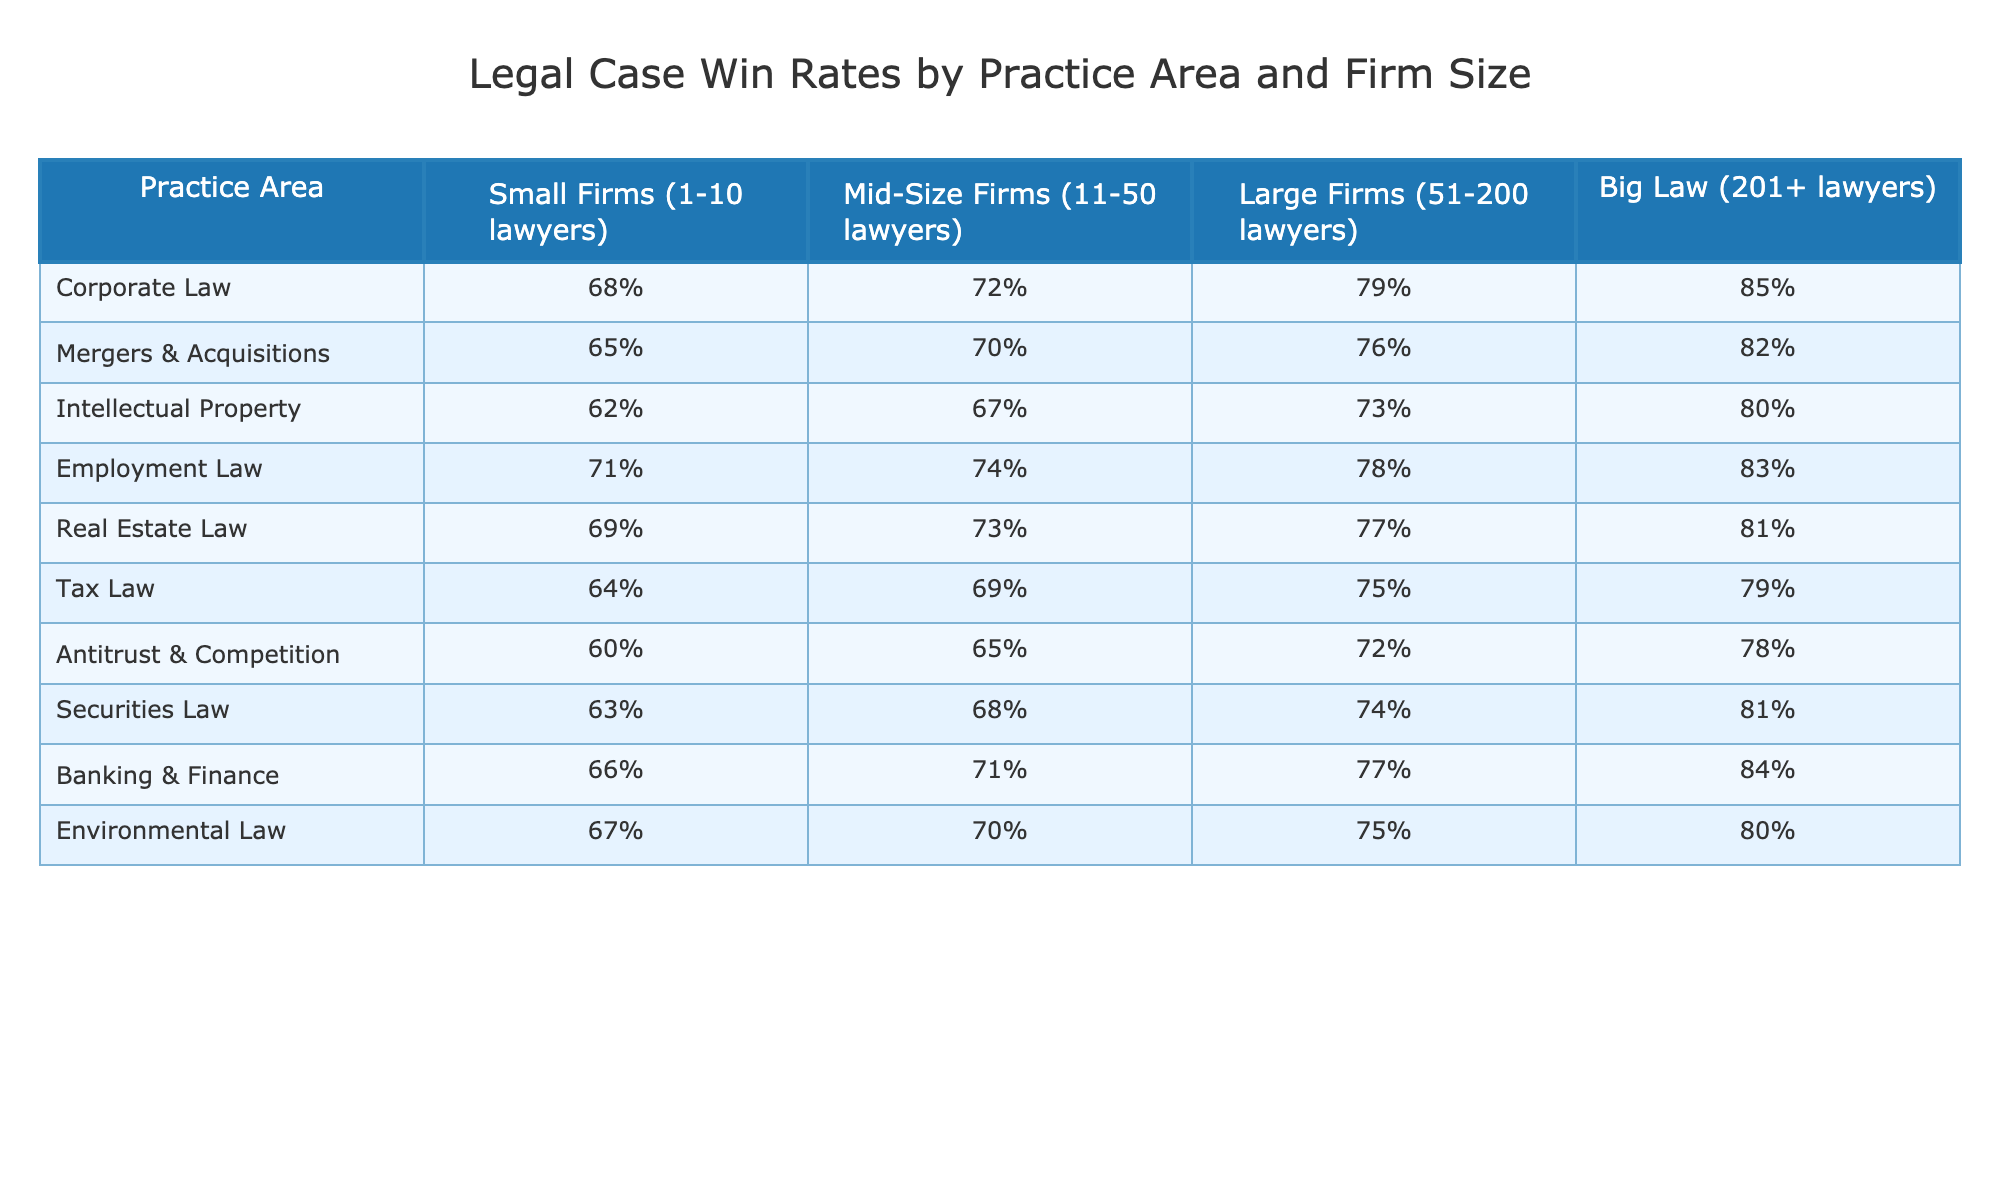What is the win rate for Employment Law in Big Law? The table shows the win rate for Employment Law in Big Law, which is represented in the last column under Big Law. Referring to the table, the win rate is 83%.
Answer: 83% Which practice area has the highest win rate for Small Firms? By reviewing the win rates for Small Firms in the table, I see that Employment Law has the highest win rate of 71%.
Answer: 71% How much higher is the win rate for Corporate Law in Big Law compared to Small Firms? The win rate for Corporate Law in Big Law is 85%, while for Small Firms, it's 68%. To find the difference, I subtract: 85% - 68% = 17%.
Answer: 17% Is the win rate for Antitrust & Competition higher in Mid-Size Firms than in Tax Law at Large Firms? The win rate for Antitrust & Competition in Mid-Size Firms is 65%, while the win rate for Tax Law at Large Firms is 75%. Since 65% is less than 75%, the answer is no.
Answer: No What is the average win rate across all practice areas for Large Firms? To find the average for Large Firms, I need to add all the win rates: (79 + 76 + 73 + 78 + 77 + 75 + 72 + 74 + 77 + 75) = 761. There are 10 practice areas, so the average is 761/10 = 76.1%.
Answer: 76.1% Which practice areas have a win rate greater than 70% for Mid-Size Firms? Checking the Mid-Size Firms column, the practice areas with a win rate greater than 70% are Corporate Law (72%), Mergers & Acquisitions (70%), Employment Law (74%), Real Estate Law (73%), and Banking & Finance (71%). This is a total of five practice areas.
Answer: 5 What is the difference in win rates between Intellectual Property in Big Law and Corporate Law in Small Firms? The win rate for Intellectual Property in Big Law is 80%, and for Corporate Law in Small Firms, it's 68%. Therefore, the difference is 80% - 68% = 12%.
Answer: 12% If you combine the win rates for Securities Law and Environmental Law in Large Firms, what is the total? The win rate for Securities Law in Large Firms is 74%, and for Environmental Law, it's 75%. Adding them together gives 74% + 75% = 149%.
Answer: 149% Which firm size has the lowest win rate for Real Estate Law? Looking at the win rates for Real Estate Law across firm sizes, Small Firms have a win rate of 69%, Mid-Size Firms have 73%, Large Firms have 77%, and Big Law has 81%. Hence, Small Firms have the lowest win rate.
Answer: Small Firms How does the win rate for Banking & Finance in Large Firms compare to that in Big Law? The win rate for Banking & Finance in Large Firms is 77%, whereas in Big Law, it is 84%. Comparing these two, 77% is lower than 84%, so the answer is it is lower in Large Firms.
Answer: Lower 